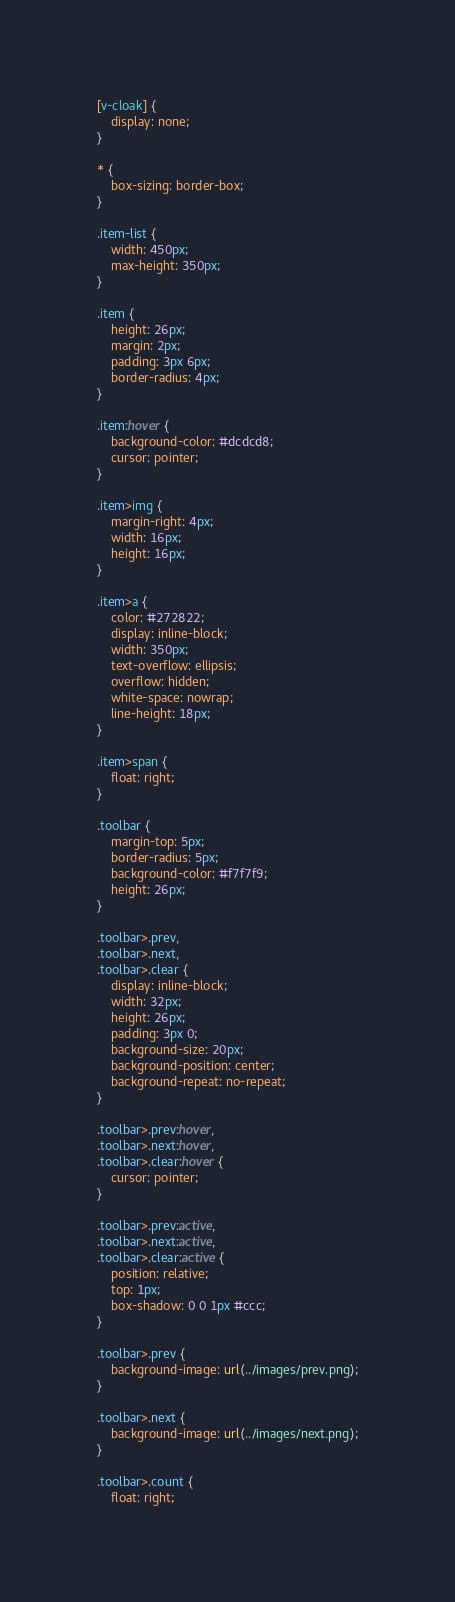Convert code to text. <code><loc_0><loc_0><loc_500><loc_500><_CSS_>[v-cloak] {
    display: none;
}

* {
    box-sizing: border-box;
}

.item-list {
    width: 450px;
    max-height: 350px;
}

.item {
    height: 26px;
    margin: 2px;
    padding: 3px 6px;
    border-radius: 4px;
}

.item:hover {
    background-color: #dcdcd8;
    cursor: pointer;
}

.item>img {
    margin-right: 4px;
    width: 16px;
    height: 16px;
}

.item>a {
    color: #272822;
    display: inline-block;
    width: 350px;
    text-overflow: ellipsis;
    overflow: hidden;
    white-space: nowrap;
    line-height: 18px;
}

.item>span {
    float: right;
}

.toolbar {
    margin-top: 5px;
    border-radius: 5px;
    background-color: #f7f7f9;
    height: 26px;
}

.toolbar>.prev,
.toolbar>.next,
.toolbar>.clear {
    display: inline-block;
    width: 32px;
    height: 26px;
    padding: 3px 0;
    background-size: 20px;
    background-position: center;
    background-repeat: no-repeat;
}

.toolbar>.prev:hover,
.toolbar>.next:hover,
.toolbar>.clear:hover {
    cursor: pointer;
}

.toolbar>.prev:active,
.toolbar>.next:active,
.toolbar>.clear:active {
    position: relative;
    top: 1px;
    box-shadow: 0 0 1px #ccc;
}

.toolbar>.prev {
    background-image: url(../images/prev.png);
}

.toolbar>.next {
    background-image: url(../images/next.png);
}

.toolbar>.count {
    float: right;</code> 